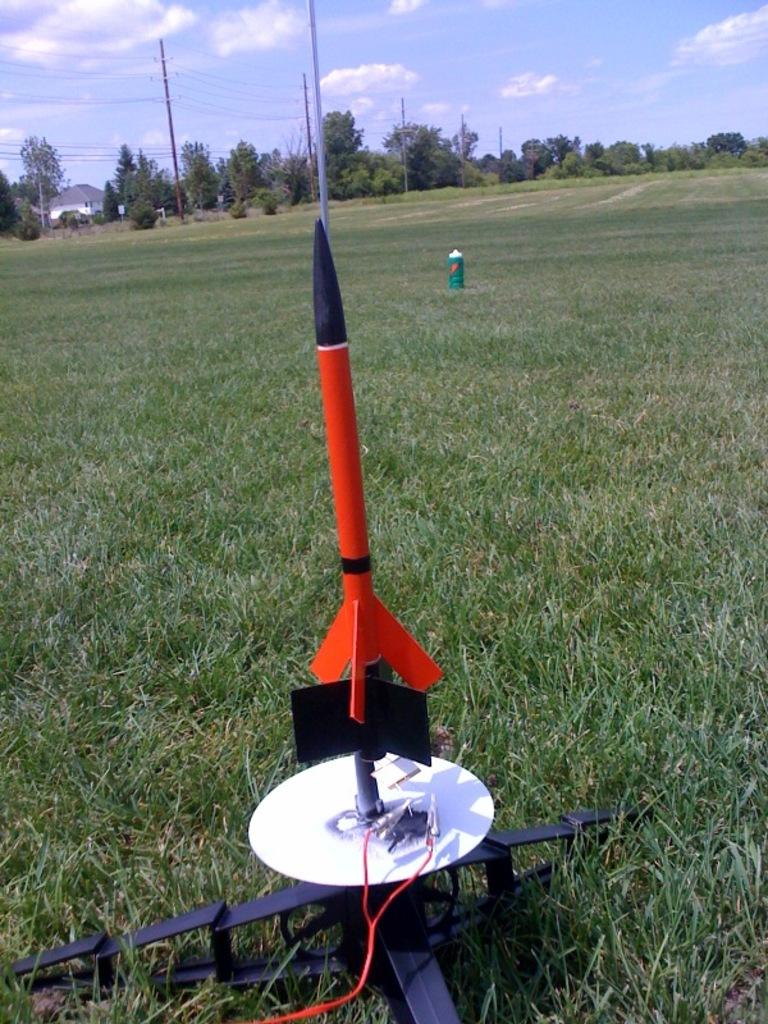What is the main subject of the image? There is a rocket in the image. What is the landscape like in the image? The land is covered with grass, and there are trees and current poles in the distance. Can you see any buildings in the image? Yes, there is a house in the distance. How many umbrellas are being used to support the rocket in the image? There are no umbrellas present in the image; the rocket is not supported by umbrellas. What type of beds can be seen in the image? There are no beds visible in the image. 